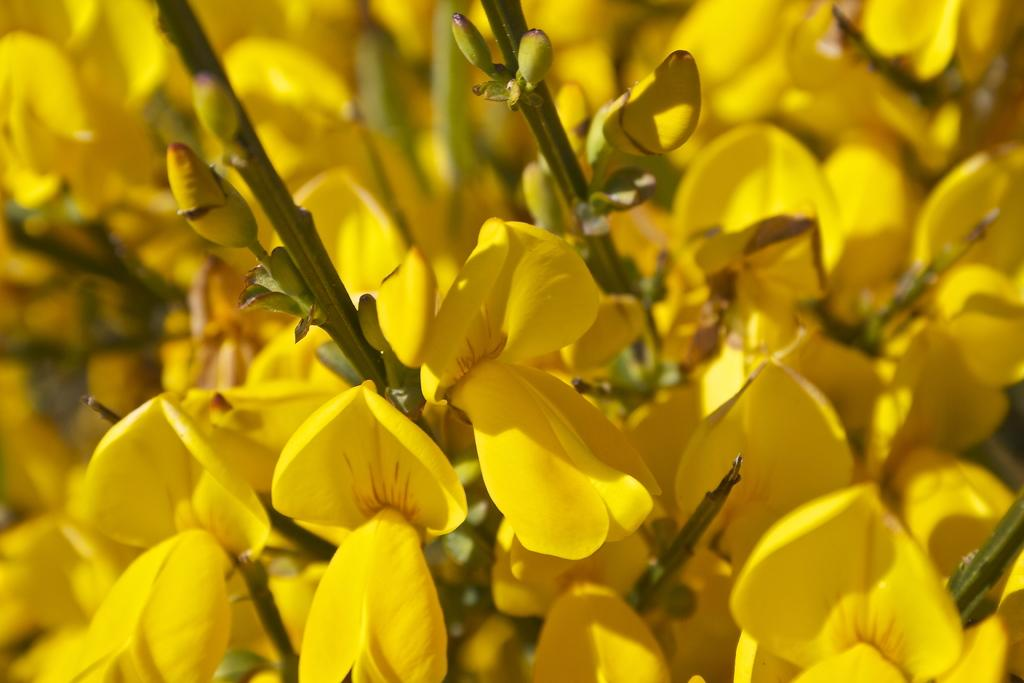What type of plants can be seen in the image? There are flowers in the image. Can you describe the stage of growth for some of the plants in the image? Yes, there are buds in the image, which are flowers in the early stages of development. How many trucks are parked near the flowers in the image? There are no trucks present in the image; it only features flowers and buds. Is there a spy observing the flowers in the image? There is no indication of a spy or any person in the image; it only features flowers and buds. 